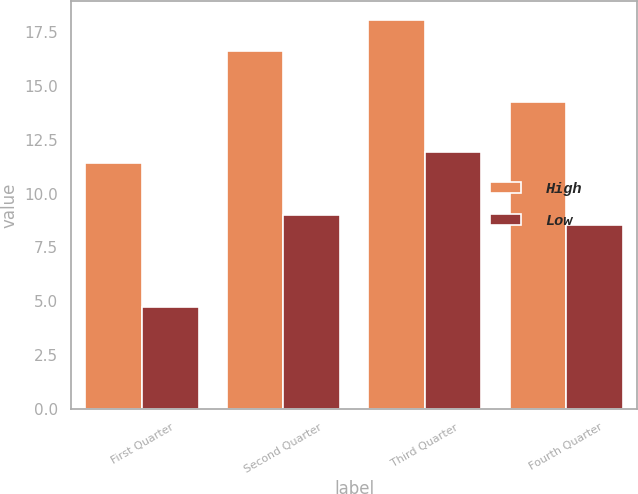Convert chart. <chart><loc_0><loc_0><loc_500><loc_500><stacked_bar_chart><ecel><fcel>First Quarter<fcel>Second Quarter<fcel>Third Quarter<fcel>Fourth Quarter<nl><fcel>High<fcel>11.44<fcel>16.6<fcel>18.05<fcel>14.24<nl><fcel>Low<fcel>4.72<fcel>8.99<fcel>11.92<fcel>8.56<nl></chart> 